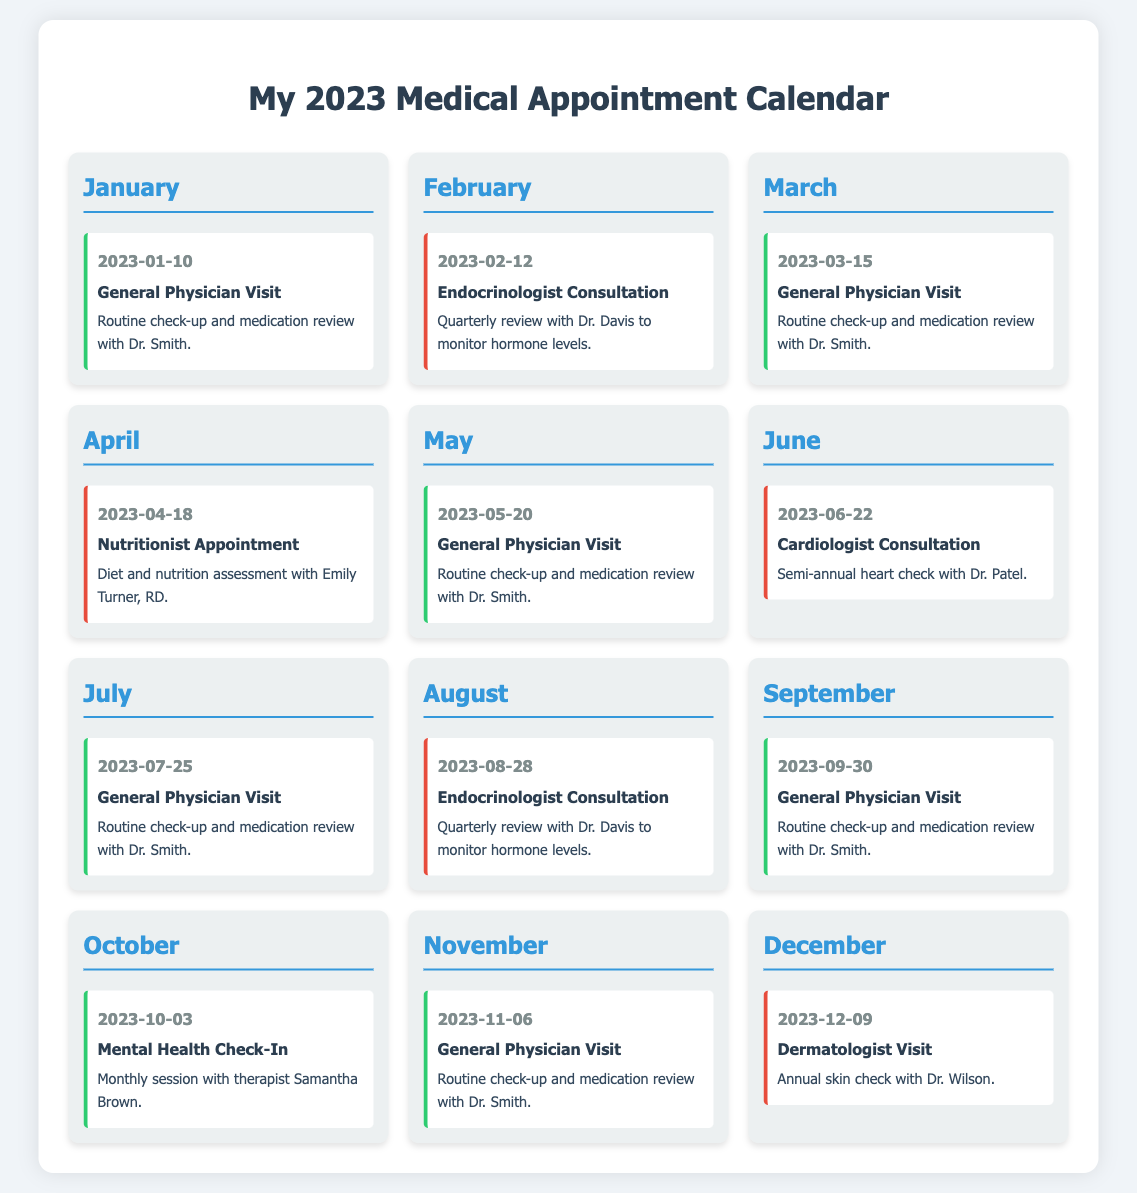What is the first appointment in 2023? The first appointment listed in the calendar is on January 10, 2023, for a General Physician Visit.
Answer: General Physician Visit How many general physician visits are scheduled for 2023? There are four scheduled General Physician Visits in the calendar.
Answer: Four What type of specialist is consulted in June? The appointment in June is with a Cardiologist.
Answer: Cardiologist What date is the Endocrinologist Consultation scheduled for in February? The Endocrinologist Consultation is scheduled for February 12, 2023.
Answer: February 12 Which month has a Mental Health Check-In appointment? The Mental Health Check-In appointment is scheduled for October.
Answer: October How many months have specialist consultations? There are four months with specialist consultations.
Answer: Four What is the last appointment of the year? The last appointment of the year is a Dermatologist Visit on December 9.
Answer: Dermatologist Visit When is the Nutritionist appointment scheduled? The Nutritionist appointment is scheduled for April 18, 2023.
Answer: April 18 Which month has the most frequent type of appointment? The months with the most frequent appointment type (General Physician Visit) are January, March, May, July, and November.
Answer: January, March, May, July, November 